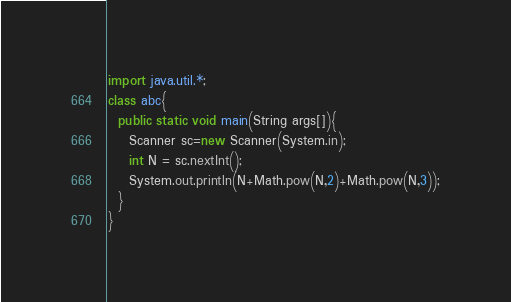Convert code to text. <code><loc_0><loc_0><loc_500><loc_500><_Java_>import java.util.*;
class abc{
  public static void main(String args[]){
    Scanner sc=new Scanner(System.in);
    int N = sc.nextInt();
    System.out.println(N+Math.pow(N,2)+Math.pow(N,3));
  }
}</code> 